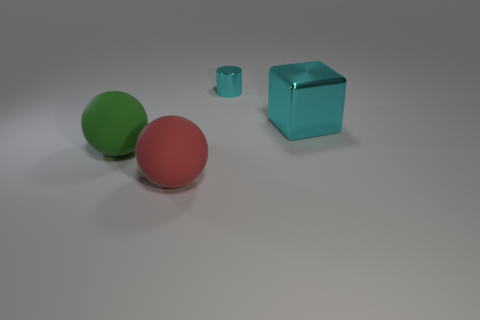Add 3 small blue blocks. How many objects exist? 7 Subtract all blocks. How many objects are left? 3 Add 4 green rubber spheres. How many green rubber spheres are left? 5 Add 2 large cyan shiny objects. How many large cyan shiny objects exist? 3 Subtract 0 yellow spheres. How many objects are left? 4 Subtract all metallic cylinders. Subtract all large blue metal cylinders. How many objects are left? 3 